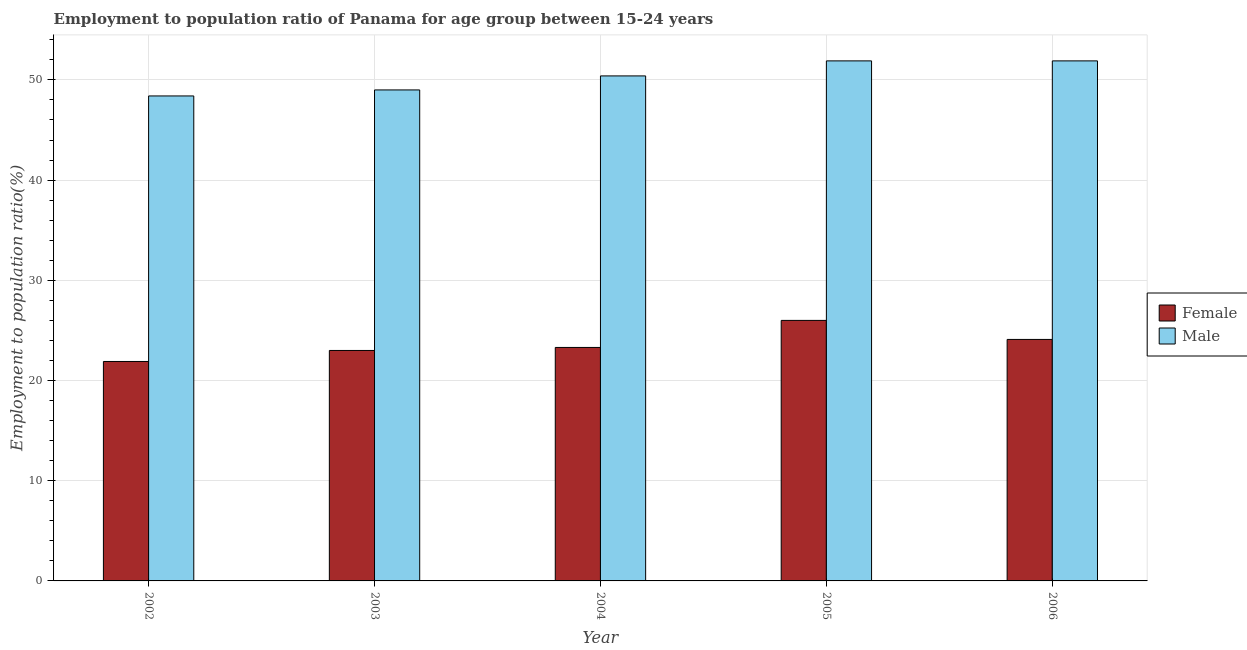How many different coloured bars are there?
Your answer should be compact. 2. How many bars are there on the 2nd tick from the left?
Your answer should be compact. 2. What is the employment to population ratio(male) in 2004?
Give a very brief answer. 50.4. Across all years, what is the maximum employment to population ratio(male)?
Offer a very short reply. 51.9. Across all years, what is the minimum employment to population ratio(male)?
Offer a terse response. 48.4. In which year was the employment to population ratio(male) minimum?
Keep it short and to the point. 2002. What is the total employment to population ratio(female) in the graph?
Provide a succinct answer. 118.3. What is the difference between the employment to population ratio(male) in 2003 and that in 2004?
Keep it short and to the point. -1.4. What is the difference between the employment to population ratio(female) in 2004 and the employment to population ratio(male) in 2002?
Your answer should be very brief. 1.4. What is the average employment to population ratio(male) per year?
Give a very brief answer. 50.32. In the year 2002, what is the difference between the employment to population ratio(male) and employment to population ratio(female)?
Offer a terse response. 0. In how many years, is the employment to population ratio(female) greater than 22 %?
Your response must be concise. 4. What is the ratio of the employment to population ratio(female) in 2003 to that in 2006?
Give a very brief answer. 0.95. What is the difference between the highest and the second highest employment to population ratio(male)?
Provide a succinct answer. 0. What is the difference between the highest and the lowest employment to population ratio(female)?
Provide a succinct answer. 4.1. In how many years, is the employment to population ratio(male) greater than the average employment to population ratio(male) taken over all years?
Offer a terse response. 3. What does the 2nd bar from the left in 2002 represents?
Provide a short and direct response. Male. What does the 1st bar from the right in 2005 represents?
Your answer should be compact. Male. How many bars are there?
Provide a short and direct response. 10. How many years are there in the graph?
Give a very brief answer. 5. What is the difference between two consecutive major ticks on the Y-axis?
Provide a short and direct response. 10. Does the graph contain any zero values?
Give a very brief answer. No. Does the graph contain grids?
Provide a short and direct response. Yes. Where does the legend appear in the graph?
Provide a short and direct response. Center right. How many legend labels are there?
Your answer should be compact. 2. How are the legend labels stacked?
Your answer should be very brief. Vertical. What is the title of the graph?
Offer a very short reply. Employment to population ratio of Panama for age group between 15-24 years. What is the Employment to population ratio(%) of Female in 2002?
Your answer should be compact. 21.9. What is the Employment to population ratio(%) of Male in 2002?
Your answer should be compact. 48.4. What is the Employment to population ratio(%) of Female in 2003?
Your answer should be compact. 23. What is the Employment to population ratio(%) of Male in 2003?
Your answer should be compact. 49. What is the Employment to population ratio(%) of Female in 2004?
Provide a succinct answer. 23.3. What is the Employment to population ratio(%) in Male in 2004?
Provide a succinct answer. 50.4. What is the Employment to population ratio(%) of Male in 2005?
Make the answer very short. 51.9. What is the Employment to population ratio(%) in Female in 2006?
Offer a very short reply. 24.1. What is the Employment to population ratio(%) in Male in 2006?
Offer a terse response. 51.9. Across all years, what is the maximum Employment to population ratio(%) in Female?
Provide a short and direct response. 26. Across all years, what is the maximum Employment to population ratio(%) of Male?
Your answer should be compact. 51.9. Across all years, what is the minimum Employment to population ratio(%) in Female?
Your answer should be very brief. 21.9. Across all years, what is the minimum Employment to population ratio(%) of Male?
Provide a short and direct response. 48.4. What is the total Employment to population ratio(%) of Female in the graph?
Your answer should be compact. 118.3. What is the total Employment to population ratio(%) of Male in the graph?
Offer a terse response. 251.6. What is the difference between the Employment to population ratio(%) of Female in 2002 and that in 2003?
Provide a short and direct response. -1.1. What is the difference between the Employment to population ratio(%) in Female in 2002 and that in 2004?
Your answer should be very brief. -1.4. What is the difference between the Employment to population ratio(%) in Male in 2002 and that in 2004?
Your answer should be very brief. -2. What is the difference between the Employment to population ratio(%) of Female in 2002 and that in 2006?
Your answer should be compact. -2.2. What is the difference between the Employment to population ratio(%) in Male in 2002 and that in 2006?
Offer a very short reply. -3.5. What is the difference between the Employment to population ratio(%) of Male in 2003 and that in 2004?
Offer a terse response. -1.4. What is the difference between the Employment to population ratio(%) in Female in 2003 and that in 2005?
Provide a short and direct response. -3. What is the difference between the Employment to population ratio(%) in Male in 2003 and that in 2005?
Ensure brevity in your answer.  -2.9. What is the difference between the Employment to population ratio(%) in Male in 2003 and that in 2006?
Your answer should be compact. -2.9. What is the difference between the Employment to population ratio(%) of Male in 2004 and that in 2005?
Make the answer very short. -1.5. What is the difference between the Employment to population ratio(%) of Female in 2004 and that in 2006?
Give a very brief answer. -0.8. What is the difference between the Employment to population ratio(%) in Male in 2005 and that in 2006?
Keep it short and to the point. 0. What is the difference between the Employment to population ratio(%) in Female in 2002 and the Employment to population ratio(%) in Male in 2003?
Your response must be concise. -27.1. What is the difference between the Employment to population ratio(%) of Female in 2002 and the Employment to population ratio(%) of Male in 2004?
Provide a succinct answer. -28.5. What is the difference between the Employment to population ratio(%) of Female in 2003 and the Employment to population ratio(%) of Male in 2004?
Your answer should be very brief. -27.4. What is the difference between the Employment to population ratio(%) of Female in 2003 and the Employment to population ratio(%) of Male in 2005?
Offer a terse response. -28.9. What is the difference between the Employment to population ratio(%) of Female in 2003 and the Employment to population ratio(%) of Male in 2006?
Provide a short and direct response. -28.9. What is the difference between the Employment to population ratio(%) of Female in 2004 and the Employment to population ratio(%) of Male in 2005?
Offer a terse response. -28.6. What is the difference between the Employment to population ratio(%) in Female in 2004 and the Employment to population ratio(%) in Male in 2006?
Provide a succinct answer. -28.6. What is the difference between the Employment to population ratio(%) of Female in 2005 and the Employment to population ratio(%) of Male in 2006?
Provide a short and direct response. -25.9. What is the average Employment to population ratio(%) of Female per year?
Your response must be concise. 23.66. What is the average Employment to population ratio(%) in Male per year?
Provide a short and direct response. 50.32. In the year 2002, what is the difference between the Employment to population ratio(%) of Female and Employment to population ratio(%) of Male?
Keep it short and to the point. -26.5. In the year 2004, what is the difference between the Employment to population ratio(%) of Female and Employment to population ratio(%) of Male?
Provide a short and direct response. -27.1. In the year 2005, what is the difference between the Employment to population ratio(%) of Female and Employment to population ratio(%) of Male?
Offer a terse response. -25.9. In the year 2006, what is the difference between the Employment to population ratio(%) in Female and Employment to population ratio(%) in Male?
Your response must be concise. -27.8. What is the ratio of the Employment to population ratio(%) of Female in 2002 to that in 2003?
Offer a very short reply. 0.95. What is the ratio of the Employment to population ratio(%) in Female in 2002 to that in 2004?
Offer a terse response. 0.94. What is the ratio of the Employment to population ratio(%) in Male in 2002 to that in 2004?
Offer a very short reply. 0.96. What is the ratio of the Employment to population ratio(%) of Female in 2002 to that in 2005?
Provide a succinct answer. 0.84. What is the ratio of the Employment to population ratio(%) in Male in 2002 to that in 2005?
Make the answer very short. 0.93. What is the ratio of the Employment to population ratio(%) of Female in 2002 to that in 2006?
Make the answer very short. 0.91. What is the ratio of the Employment to population ratio(%) of Male in 2002 to that in 2006?
Make the answer very short. 0.93. What is the ratio of the Employment to population ratio(%) of Female in 2003 to that in 2004?
Your answer should be compact. 0.99. What is the ratio of the Employment to population ratio(%) in Male in 2003 to that in 2004?
Make the answer very short. 0.97. What is the ratio of the Employment to population ratio(%) in Female in 2003 to that in 2005?
Provide a succinct answer. 0.88. What is the ratio of the Employment to population ratio(%) in Male in 2003 to that in 2005?
Give a very brief answer. 0.94. What is the ratio of the Employment to population ratio(%) in Female in 2003 to that in 2006?
Your answer should be compact. 0.95. What is the ratio of the Employment to population ratio(%) in Male in 2003 to that in 2006?
Provide a succinct answer. 0.94. What is the ratio of the Employment to population ratio(%) in Female in 2004 to that in 2005?
Give a very brief answer. 0.9. What is the ratio of the Employment to population ratio(%) in Male in 2004 to that in 2005?
Provide a short and direct response. 0.97. What is the ratio of the Employment to population ratio(%) in Female in 2004 to that in 2006?
Ensure brevity in your answer.  0.97. What is the ratio of the Employment to population ratio(%) of Male in 2004 to that in 2006?
Your answer should be compact. 0.97. What is the ratio of the Employment to population ratio(%) of Female in 2005 to that in 2006?
Provide a short and direct response. 1.08. What is the ratio of the Employment to population ratio(%) in Male in 2005 to that in 2006?
Your answer should be very brief. 1. What is the difference between the highest and the second highest Employment to population ratio(%) of Female?
Keep it short and to the point. 1.9. What is the difference between the highest and the lowest Employment to population ratio(%) in Female?
Offer a terse response. 4.1. What is the difference between the highest and the lowest Employment to population ratio(%) in Male?
Your answer should be compact. 3.5. 